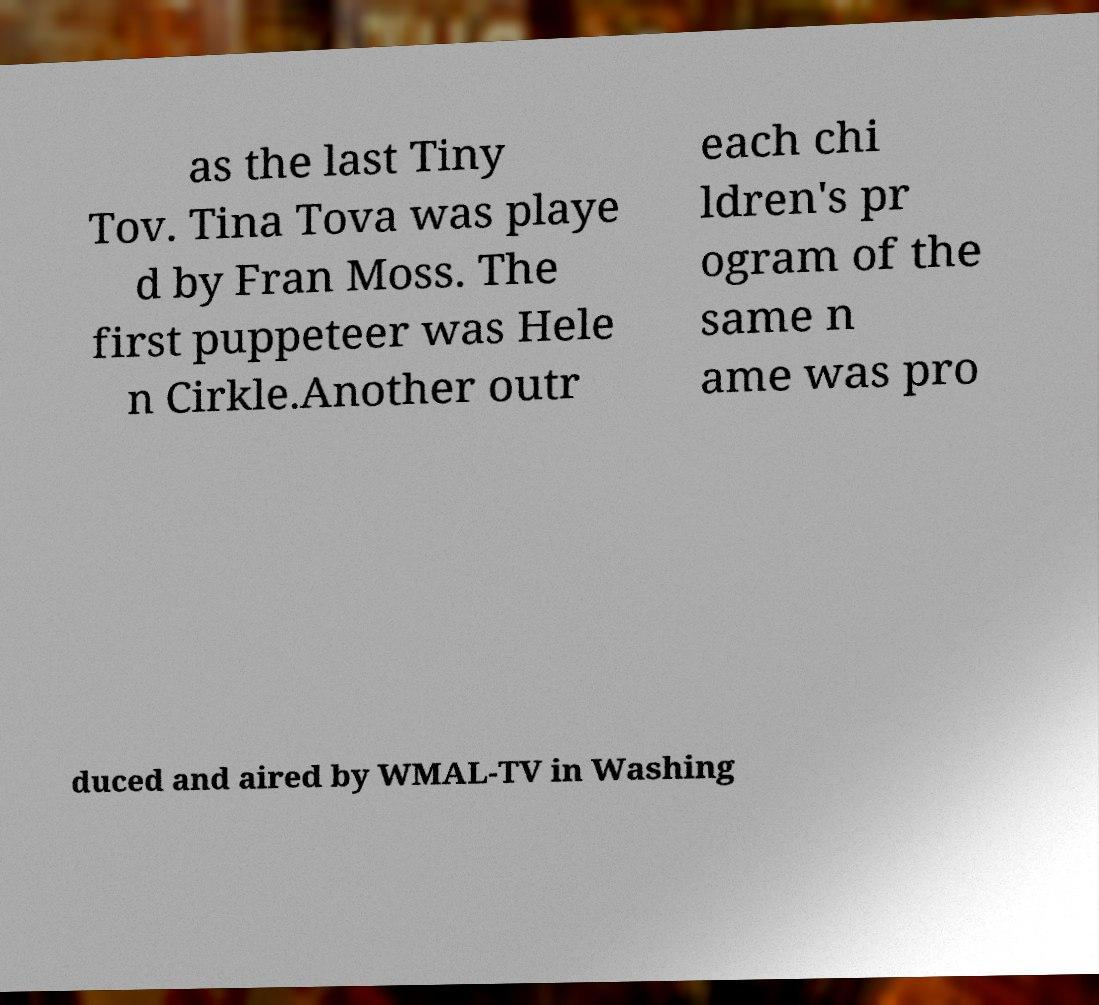Can you accurately transcribe the text from the provided image for me? as the last Tiny Tov. Tina Tova was playe d by Fran Moss. The first puppeteer was Hele n Cirkle.Another outr each chi ldren's pr ogram of the same n ame was pro duced and aired by WMAL-TV in Washing 